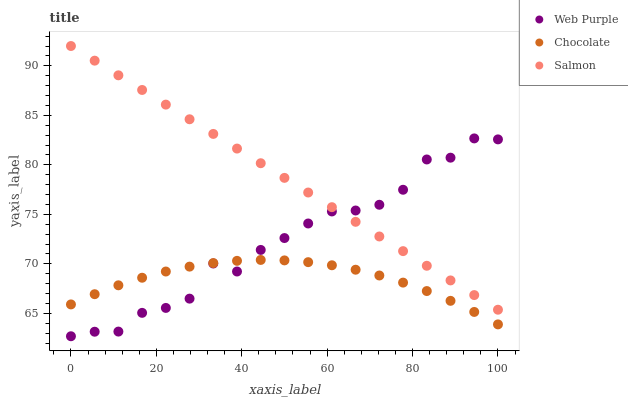Does Chocolate have the minimum area under the curve?
Answer yes or no. Yes. Does Salmon have the maximum area under the curve?
Answer yes or no. Yes. Does Salmon have the minimum area under the curve?
Answer yes or no. No. Does Chocolate have the maximum area under the curve?
Answer yes or no. No. Is Salmon the smoothest?
Answer yes or no. Yes. Is Web Purple the roughest?
Answer yes or no. Yes. Is Chocolate the smoothest?
Answer yes or no. No. Is Chocolate the roughest?
Answer yes or no. No. Does Web Purple have the lowest value?
Answer yes or no. Yes. Does Chocolate have the lowest value?
Answer yes or no. No. Does Salmon have the highest value?
Answer yes or no. Yes. Does Chocolate have the highest value?
Answer yes or no. No. Is Chocolate less than Salmon?
Answer yes or no. Yes. Is Salmon greater than Chocolate?
Answer yes or no. Yes. Does Web Purple intersect Chocolate?
Answer yes or no. Yes. Is Web Purple less than Chocolate?
Answer yes or no. No. Is Web Purple greater than Chocolate?
Answer yes or no. No. Does Chocolate intersect Salmon?
Answer yes or no. No. 